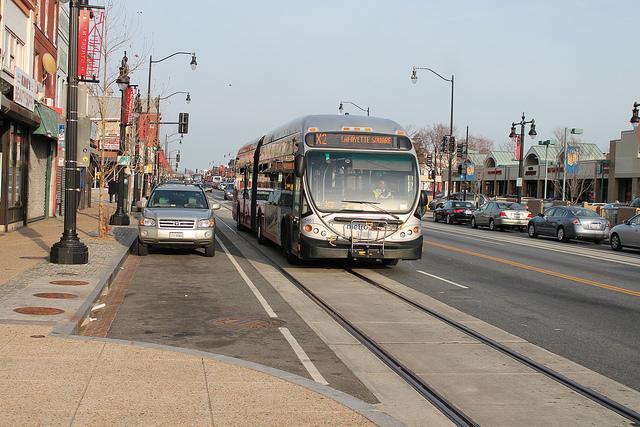How many cars are there?
Give a very brief answer. 2. 